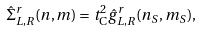<formula> <loc_0><loc_0><loc_500><loc_500>\hat { \Sigma } ^ { r } _ { L , R } ( { n } , { m } ) = t _ { \text  C}^{2} \hat{g}_{L,R}^{r}({ n}_{S},{ m}_{S}),</formula> 